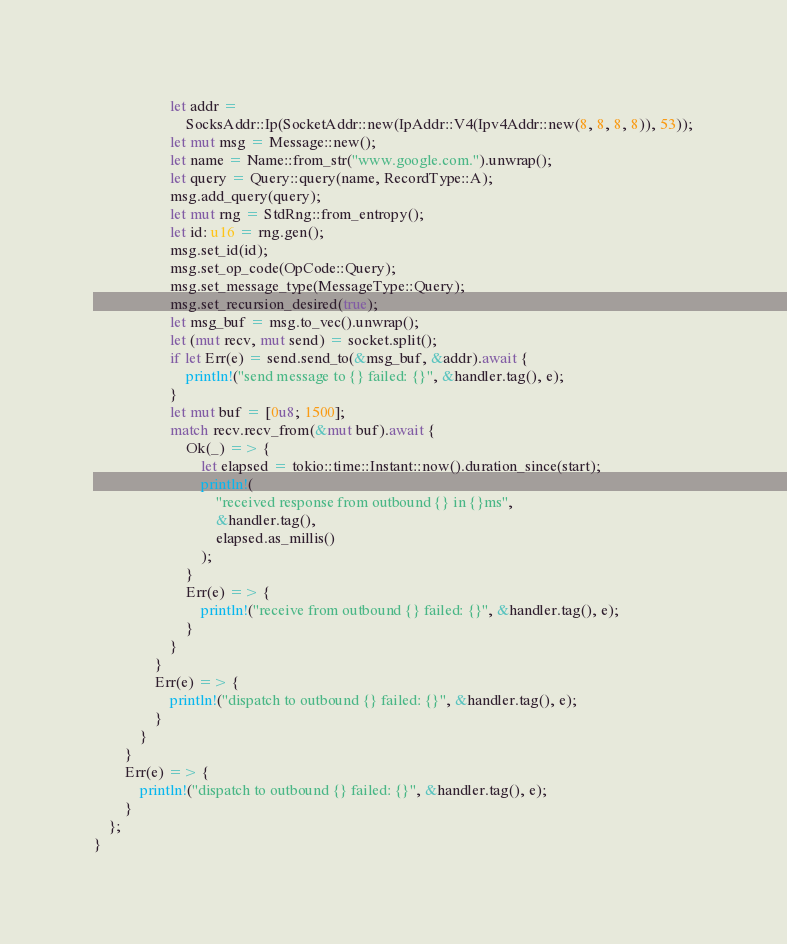<code> <loc_0><loc_0><loc_500><loc_500><_Rust_>                    let addr =
                        SocksAddr::Ip(SocketAddr::new(IpAddr::V4(Ipv4Addr::new(8, 8, 8, 8)), 53));
                    let mut msg = Message::new();
                    let name = Name::from_str("www.google.com.").unwrap();
                    let query = Query::query(name, RecordType::A);
                    msg.add_query(query);
                    let mut rng = StdRng::from_entropy();
                    let id: u16 = rng.gen();
                    msg.set_id(id);
                    msg.set_op_code(OpCode::Query);
                    msg.set_message_type(MessageType::Query);
                    msg.set_recursion_desired(true);
                    let msg_buf = msg.to_vec().unwrap();
                    let (mut recv, mut send) = socket.split();
                    if let Err(e) = send.send_to(&msg_buf, &addr).await {
                        println!("send message to {} failed: {}", &handler.tag(), e);
                    }
                    let mut buf = [0u8; 1500];
                    match recv.recv_from(&mut buf).await {
                        Ok(_) => {
                            let elapsed = tokio::time::Instant::now().duration_since(start);
                            println!(
                                "received response from outbound {} in {}ms",
                                &handler.tag(),
                                elapsed.as_millis()
                            );
                        }
                        Err(e) => {
                            println!("receive from outbound {} failed: {}", &handler.tag(), e);
                        }
                    }
                }
                Err(e) => {
                    println!("dispatch to outbound {} failed: {}", &handler.tag(), e);
                }
            }
        }
        Err(e) => {
            println!("dispatch to outbound {} failed: {}", &handler.tag(), e);
        }
    };
}
</code> 